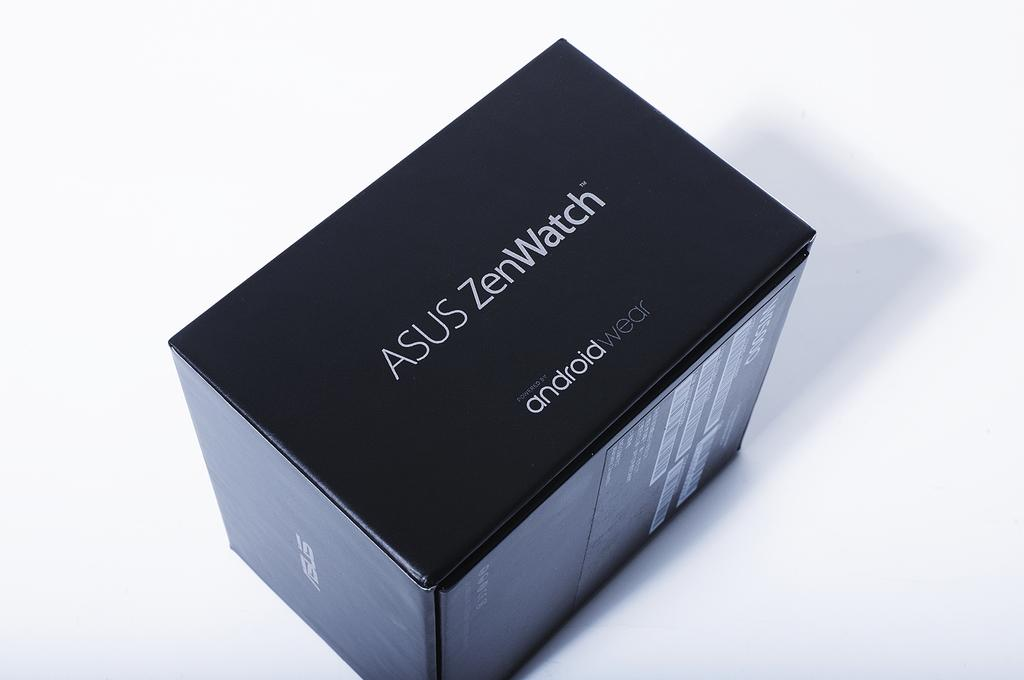<image>
Create a compact narrative representing the image presented. A box for an Asus brand zenwatch android watch. 